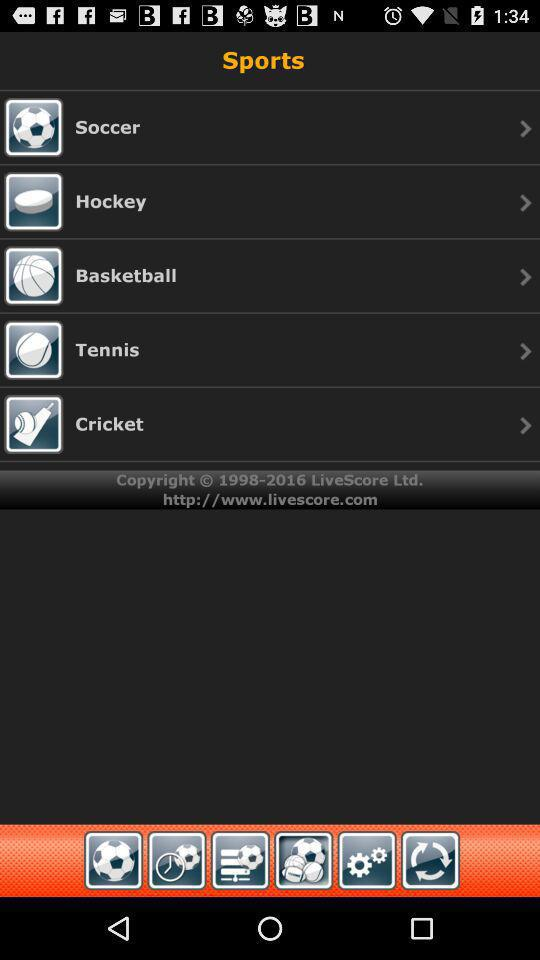How many sports are available in the app?
Answer the question using a single word or phrase. 5 